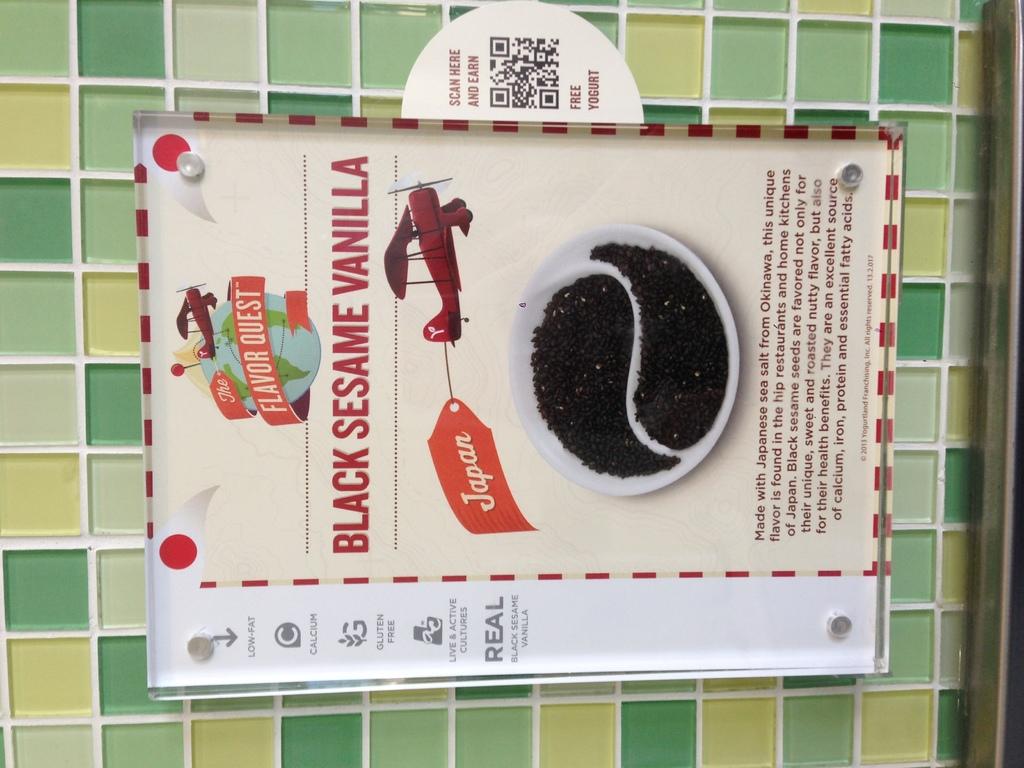What is the type of vanilla?
Keep it short and to the point. Black sesame. 